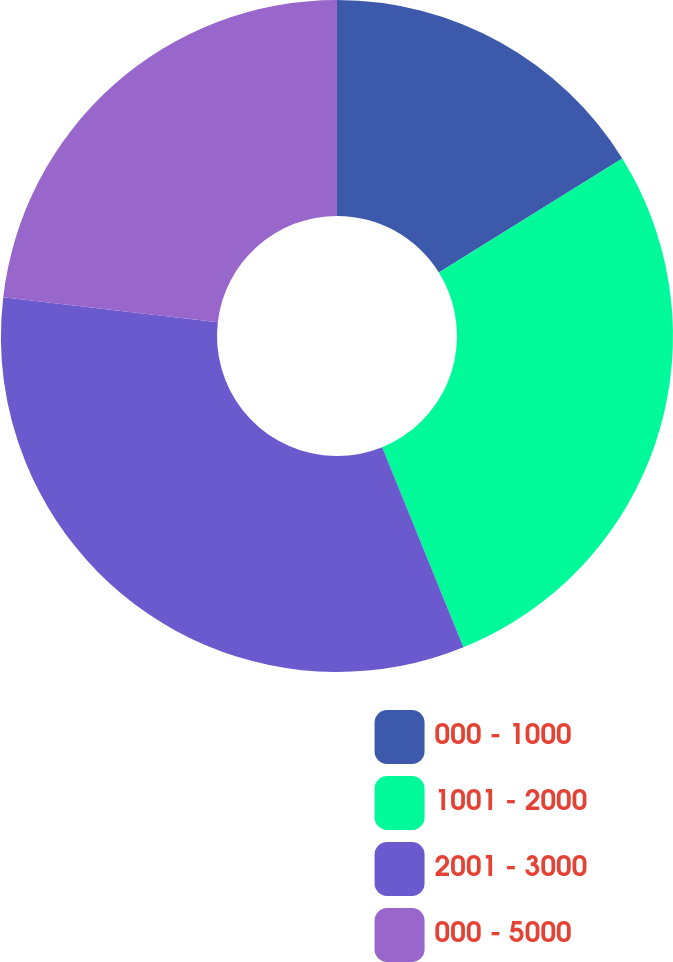Convert chart to OTSL. <chart><loc_0><loc_0><loc_500><loc_500><pie_chart><fcel>000 - 1000<fcel>1001 - 2000<fcel>2001 - 3000<fcel>000 - 5000<nl><fcel>16.14%<fcel>27.72%<fcel>32.98%<fcel>23.16%<nl></chart> 